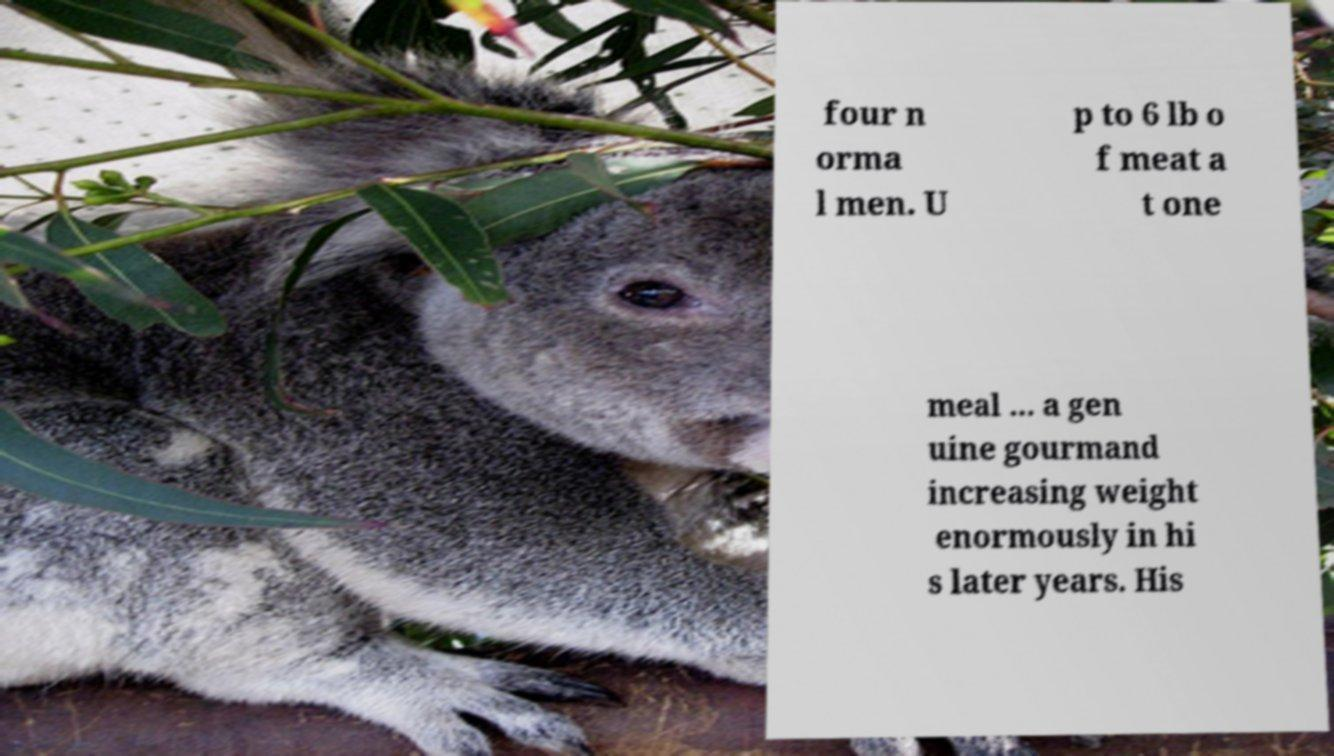Can you accurately transcribe the text from the provided image for me? four n orma l men. U p to 6 lb o f meat a t one meal ... a gen uine gourmand increasing weight enormously in hi s later years. His 